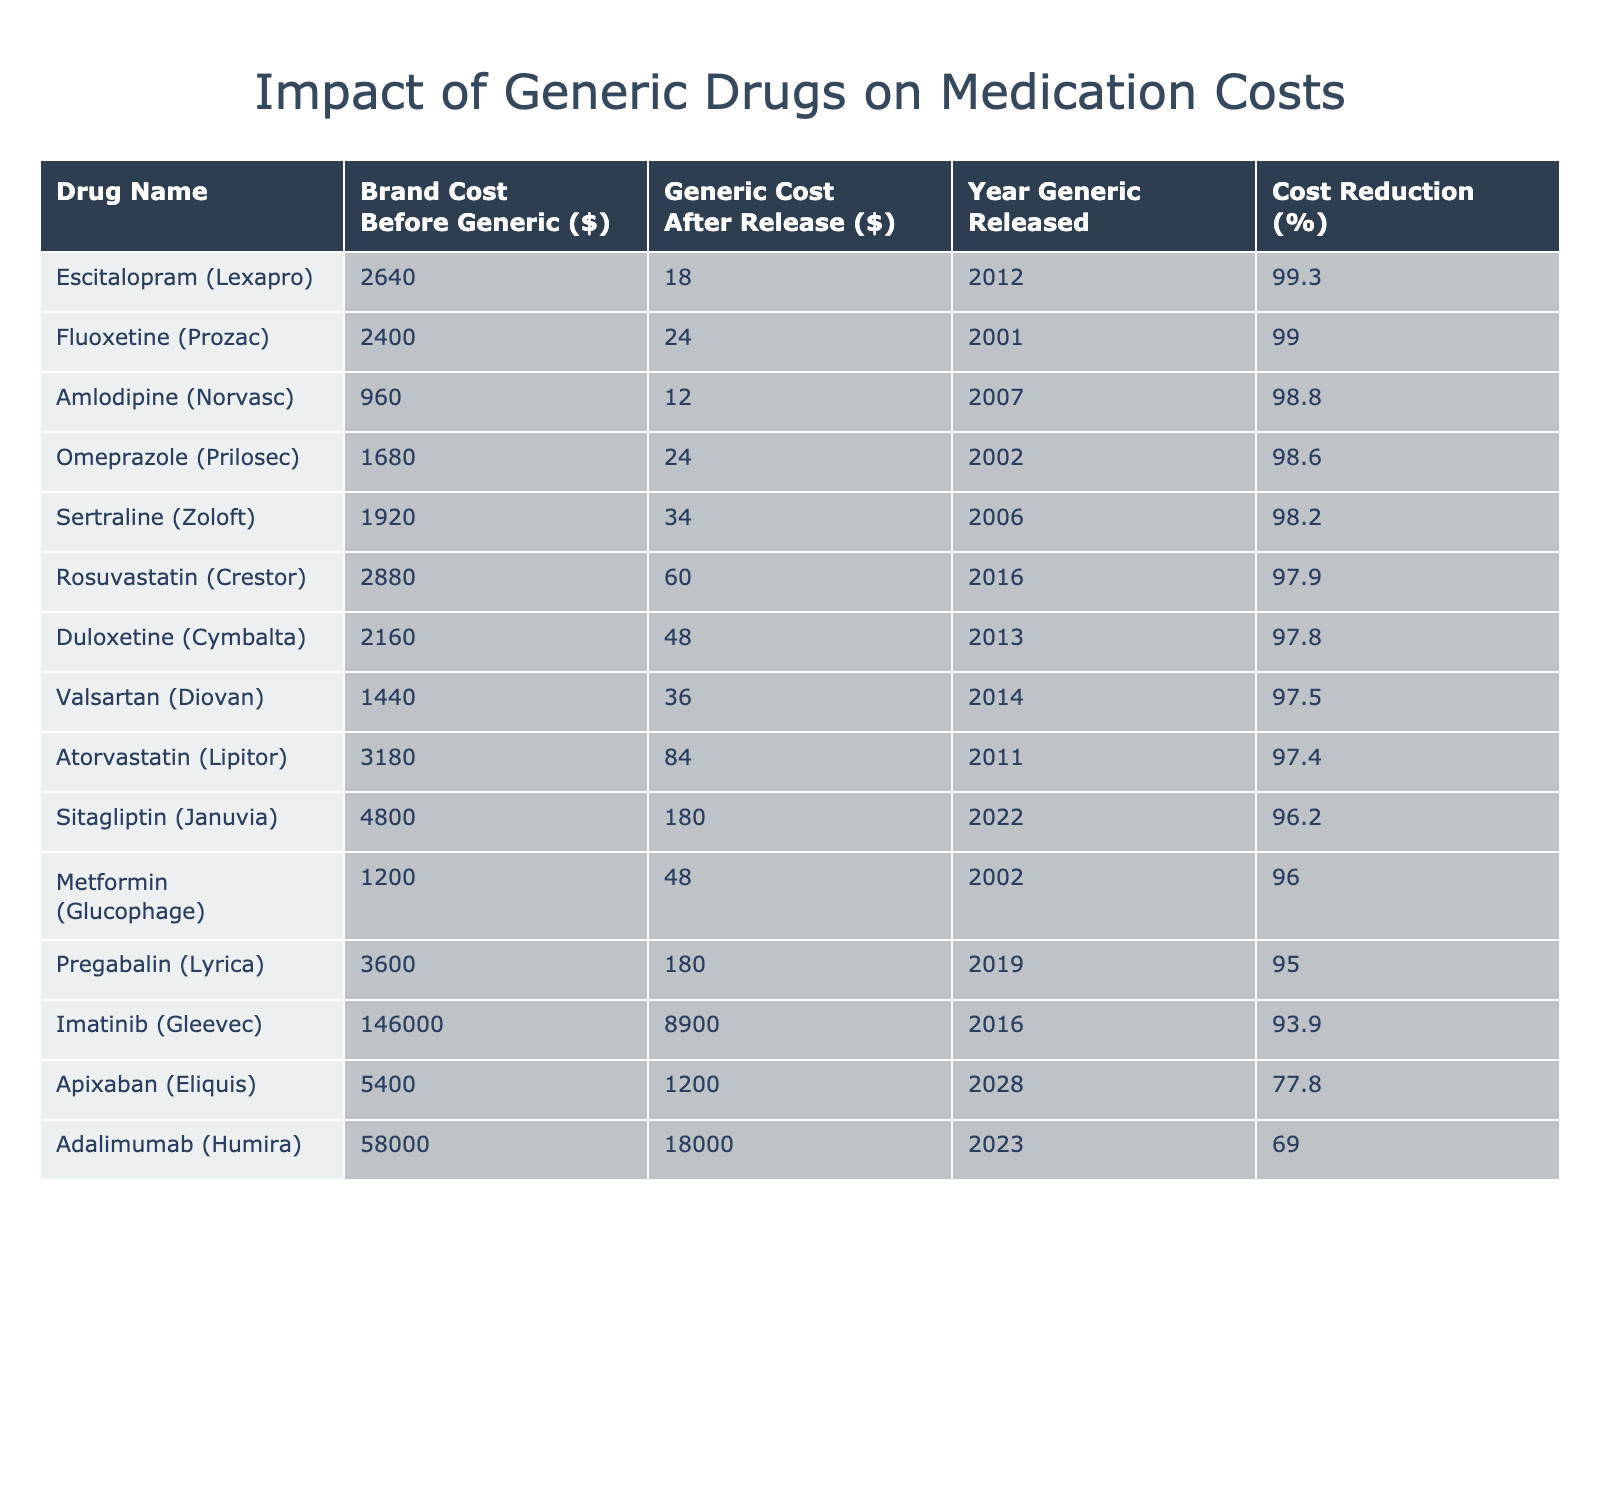What was the brand cost of Imatinib (Gleevec) before the generic version was released? The table indicates that the brand cost before the generic version for Imatinib (Gleevec) was $146,000.
Answer: $146,000 What is the cost reduction percentage for Atorvastatin (Lipitor)? To find the cost reduction percentage, subtract the generic cost ($84) from the brand cost ($3,180), divide by the brand cost, and multiply by 100: ((3180 - 84) / 3180) * 100 = 97.4%.
Answer: 97.4% Which drug had the highest cost reduction percentage and what was that percentage? The table shows that Imatinib (Gleevec) had the highest cost reduction percentage of 93.9%.
Answer: 93.9% Is the generic cost of Apixaban (Eliquis) higher than the brand cost of Metformin (Glucophage)? From the table, Apixaban (Eliquis) has a generic cost of $1,200 and Metformin (Glucophage) has a brand cost of $1,200. Therefore, it is not true that Apixaban's generic cost is higher than Metformin's brand cost.
Answer: No How much did the cost of duloxetine (Cymbalta) drop after the release of the generic version? The brand cost of duloxetine (Cymbalta) was $2,160 and the generic cost was $48. The drop in cost is calculated as $2,160 - $48 = $2,112.
Answer: $2,112 What is the average brand cost of the drugs in this table before generics were released? To find the average brand cost, sum all brand costs: $146,000 + $3,180 + $2,400 + $1,920 + $2,640 + $1,200 + $960 + $1,680 + $2,880 + $1,440 + $2,160 + $3,600 + $4,800 + $5,400 + $58,000 = $222,720. Then divide by 15 (the number of drugs), which gives $14,914.67.
Answer: $14,914.67 What year was the generic version of Sertraline (Zoloft) released? Referring to the table, the generic version of Sertraline (Zoloft) was released in 2006.
Answer: 2006 Which drug has the minimal cost after the generic version was released? The table shows that the drug with the lowest cost after the generic release is Amlodipine (Norvasc) at $12.
Answer: $12 Compare the brand cost and the generic cost of Adalimumab (Humira) to see if the generic is more than 30% less expensive. The brand cost of Adalimumab (Humira) is $58,000 and the generic cost is $18,000. The savings percentage is calculated as ((58000 - 18000) / 58000) * 100 = 68.97%. Thus, the generic is significantly less than 30% cheaper.
Answer: Yes, it is Which two drugs had a cost reduction percentage of over 90%? Reviewing the table, Imatinib (Gleevec) and Atorvastatin (Lipitor) both had cost reductions over 90%, with Imatinib at 93.9% and Atorvastatin at 97.4%.
Answer: Imatinib (Gleevec) and Atorvastatin (Lipitor) 